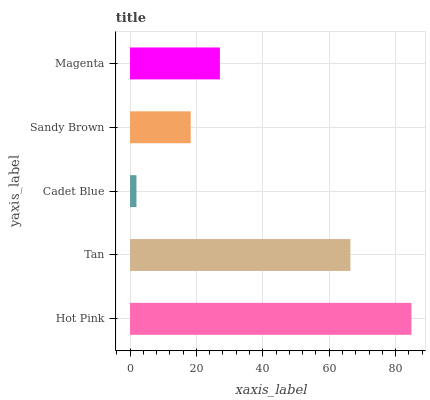Is Cadet Blue the minimum?
Answer yes or no. Yes. Is Hot Pink the maximum?
Answer yes or no. Yes. Is Tan the minimum?
Answer yes or no. No. Is Tan the maximum?
Answer yes or no. No. Is Hot Pink greater than Tan?
Answer yes or no. Yes. Is Tan less than Hot Pink?
Answer yes or no. Yes. Is Tan greater than Hot Pink?
Answer yes or no. No. Is Hot Pink less than Tan?
Answer yes or no. No. Is Magenta the high median?
Answer yes or no. Yes. Is Magenta the low median?
Answer yes or no. Yes. Is Sandy Brown the high median?
Answer yes or no. No. Is Cadet Blue the low median?
Answer yes or no. No. 